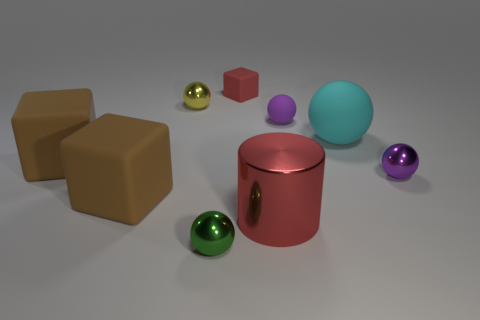How many other objects are there of the same size as the red metallic object?
Make the answer very short. 3. There is a brown rubber object in front of the purple shiny sphere; does it have the same size as the cube that is on the right side of the tiny green ball?
Provide a succinct answer. No. What number of other rubber blocks are the same color as the small cube?
Keep it short and to the point. 0. What number of tiny objects are green balls or rubber spheres?
Keep it short and to the point. 2. Do the big sphere that is right of the purple rubber sphere and the small block have the same material?
Keep it short and to the point. Yes. There is a tiny shiny object that is on the right side of the red rubber thing; what is its color?
Give a very brief answer. Purple. Is there a green rubber block that has the same size as the purple metal sphere?
Make the answer very short. No. What material is the sphere that is the same size as the red cylinder?
Give a very brief answer. Rubber. Is the size of the red metal object the same as the rubber thing that is behind the tiny yellow metallic ball?
Offer a very short reply. No. There is a small sphere in front of the red metal object; what material is it?
Your answer should be compact. Metal. 